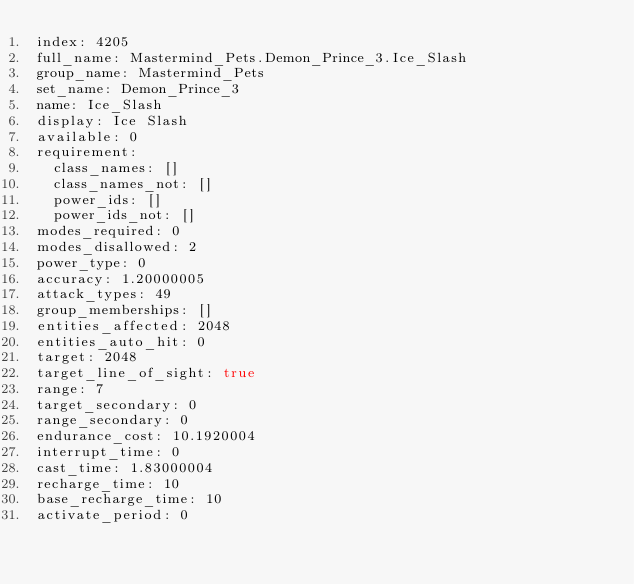Convert code to text. <code><loc_0><loc_0><loc_500><loc_500><_YAML_>index: 4205
full_name: Mastermind_Pets.Demon_Prince_3.Ice_Slash
group_name: Mastermind_Pets
set_name: Demon_Prince_3
name: Ice_Slash
display: Ice Slash
available: 0
requirement:
  class_names: []
  class_names_not: []
  power_ids: []
  power_ids_not: []
modes_required: 0
modes_disallowed: 2
power_type: 0
accuracy: 1.20000005
attack_types: 49
group_memberships: []
entities_affected: 2048
entities_auto_hit: 0
target: 2048
target_line_of_sight: true
range: 7
target_secondary: 0
range_secondary: 0
endurance_cost: 10.1920004
interrupt_time: 0
cast_time: 1.83000004
recharge_time: 10
base_recharge_time: 10
activate_period: 0</code> 